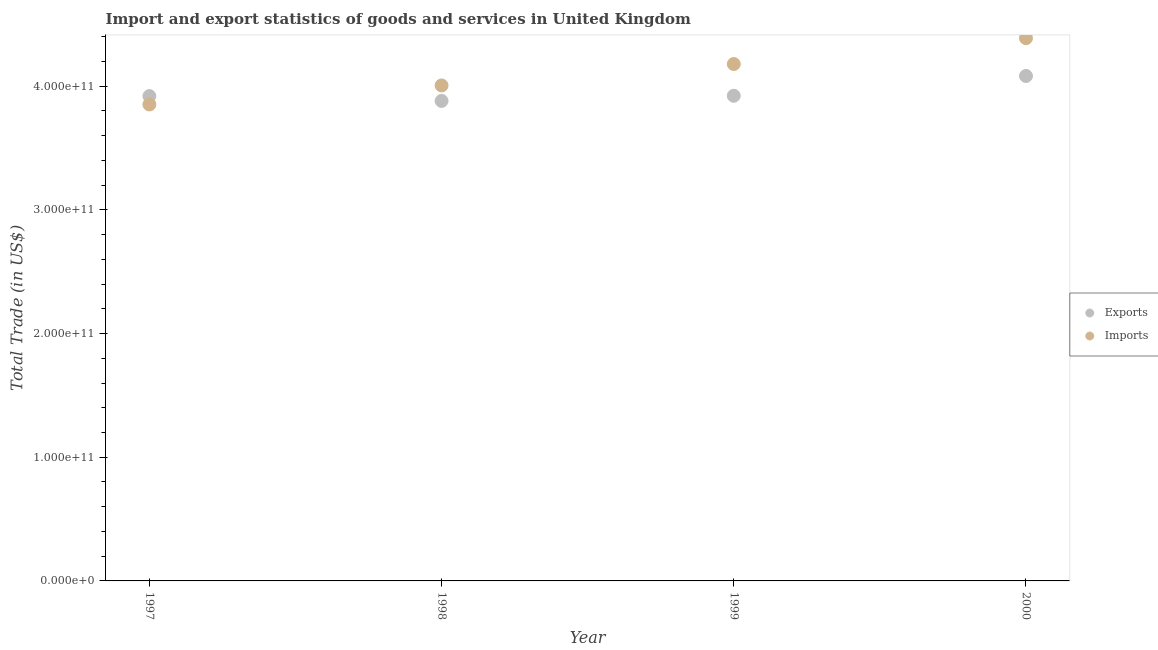Is the number of dotlines equal to the number of legend labels?
Ensure brevity in your answer.  Yes. What is the imports of goods and services in 2000?
Provide a succinct answer. 4.39e+11. Across all years, what is the maximum imports of goods and services?
Your answer should be very brief. 4.39e+11. Across all years, what is the minimum imports of goods and services?
Your response must be concise. 3.85e+11. What is the total export of goods and services in the graph?
Make the answer very short. 1.58e+12. What is the difference between the imports of goods and services in 1997 and that in 2000?
Ensure brevity in your answer.  -5.36e+1. What is the difference between the imports of goods and services in 1999 and the export of goods and services in 2000?
Your answer should be very brief. 9.66e+09. What is the average imports of goods and services per year?
Give a very brief answer. 4.11e+11. In the year 2000, what is the difference between the imports of goods and services and export of goods and services?
Offer a terse response. 3.05e+1. In how many years, is the imports of goods and services greater than 320000000000 US$?
Give a very brief answer. 4. What is the ratio of the imports of goods and services in 1998 to that in 1999?
Provide a short and direct response. 0.96. What is the difference between the highest and the second highest export of goods and services?
Provide a short and direct response. 1.60e+1. What is the difference between the highest and the lowest export of goods and services?
Provide a succinct answer. 2.02e+1. In how many years, is the imports of goods and services greater than the average imports of goods and services taken over all years?
Offer a very short reply. 2. Is the sum of the export of goods and services in 1999 and 2000 greater than the maximum imports of goods and services across all years?
Your answer should be very brief. Yes. Does the imports of goods and services monotonically increase over the years?
Make the answer very short. Yes. Is the imports of goods and services strictly less than the export of goods and services over the years?
Offer a terse response. No. How many dotlines are there?
Offer a very short reply. 2. What is the difference between two consecutive major ticks on the Y-axis?
Your answer should be compact. 1.00e+11. Does the graph contain grids?
Give a very brief answer. No. Where does the legend appear in the graph?
Give a very brief answer. Center right. How many legend labels are there?
Ensure brevity in your answer.  2. How are the legend labels stacked?
Your answer should be compact. Vertical. What is the title of the graph?
Give a very brief answer. Import and export statistics of goods and services in United Kingdom. Does "Goods and services" appear as one of the legend labels in the graph?
Make the answer very short. No. What is the label or title of the Y-axis?
Your answer should be very brief. Total Trade (in US$). What is the Total Trade (in US$) in Exports in 1997?
Your answer should be compact. 3.92e+11. What is the Total Trade (in US$) of Imports in 1997?
Give a very brief answer. 3.85e+11. What is the Total Trade (in US$) in Exports in 1998?
Your answer should be very brief. 3.88e+11. What is the Total Trade (in US$) of Imports in 1998?
Provide a succinct answer. 4.01e+11. What is the Total Trade (in US$) of Exports in 1999?
Your answer should be very brief. 3.92e+11. What is the Total Trade (in US$) of Imports in 1999?
Your response must be concise. 4.18e+11. What is the Total Trade (in US$) of Exports in 2000?
Give a very brief answer. 4.08e+11. What is the Total Trade (in US$) of Imports in 2000?
Provide a succinct answer. 4.39e+11. Across all years, what is the maximum Total Trade (in US$) of Exports?
Keep it short and to the point. 4.08e+11. Across all years, what is the maximum Total Trade (in US$) of Imports?
Keep it short and to the point. 4.39e+11. Across all years, what is the minimum Total Trade (in US$) in Exports?
Offer a terse response. 3.88e+11. Across all years, what is the minimum Total Trade (in US$) of Imports?
Make the answer very short. 3.85e+11. What is the total Total Trade (in US$) in Exports in the graph?
Ensure brevity in your answer.  1.58e+12. What is the total Total Trade (in US$) of Imports in the graph?
Offer a terse response. 1.64e+12. What is the difference between the Total Trade (in US$) of Exports in 1997 and that in 1998?
Provide a succinct answer. 3.92e+09. What is the difference between the Total Trade (in US$) in Imports in 1997 and that in 1998?
Offer a very short reply. -1.54e+1. What is the difference between the Total Trade (in US$) in Exports in 1997 and that in 1999?
Keep it short and to the point. -2.45e+08. What is the difference between the Total Trade (in US$) in Imports in 1997 and that in 1999?
Your response must be concise. -3.27e+1. What is the difference between the Total Trade (in US$) in Exports in 1997 and that in 2000?
Make the answer very short. -1.63e+1. What is the difference between the Total Trade (in US$) of Imports in 1997 and that in 2000?
Provide a succinct answer. -5.36e+1. What is the difference between the Total Trade (in US$) in Exports in 1998 and that in 1999?
Offer a terse response. -4.17e+09. What is the difference between the Total Trade (in US$) in Imports in 1998 and that in 1999?
Make the answer very short. -1.73e+1. What is the difference between the Total Trade (in US$) of Exports in 1998 and that in 2000?
Give a very brief answer. -2.02e+1. What is the difference between the Total Trade (in US$) of Imports in 1998 and that in 2000?
Your answer should be compact. -3.82e+1. What is the difference between the Total Trade (in US$) in Exports in 1999 and that in 2000?
Provide a short and direct response. -1.60e+1. What is the difference between the Total Trade (in US$) in Imports in 1999 and that in 2000?
Give a very brief answer. -2.09e+1. What is the difference between the Total Trade (in US$) in Exports in 1997 and the Total Trade (in US$) in Imports in 1998?
Provide a short and direct response. -8.60e+09. What is the difference between the Total Trade (in US$) in Exports in 1997 and the Total Trade (in US$) in Imports in 1999?
Make the answer very short. -2.59e+1. What is the difference between the Total Trade (in US$) of Exports in 1997 and the Total Trade (in US$) of Imports in 2000?
Your answer should be compact. -4.68e+1. What is the difference between the Total Trade (in US$) of Exports in 1998 and the Total Trade (in US$) of Imports in 1999?
Keep it short and to the point. -2.98e+1. What is the difference between the Total Trade (in US$) of Exports in 1998 and the Total Trade (in US$) of Imports in 2000?
Your answer should be compact. -5.07e+1. What is the difference between the Total Trade (in US$) of Exports in 1999 and the Total Trade (in US$) of Imports in 2000?
Ensure brevity in your answer.  -4.66e+1. What is the average Total Trade (in US$) of Exports per year?
Provide a short and direct response. 3.95e+11. What is the average Total Trade (in US$) in Imports per year?
Provide a short and direct response. 4.11e+11. In the year 1997, what is the difference between the Total Trade (in US$) in Exports and Total Trade (in US$) in Imports?
Provide a short and direct response. 6.78e+09. In the year 1998, what is the difference between the Total Trade (in US$) of Exports and Total Trade (in US$) of Imports?
Give a very brief answer. -1.25e+1. In the year 1999, what is the difference between the Total Trade (in US$) of Exports and Total Trade (in US$) of Imports?
Your response must be concise. -2.57e+1. In the year 2000, what is the difference between the Total Trade (in US$) of Exports and Total Trade (in US$) of Imports?
Provide a short and direct response. -3.05e+1. What is the ratio of the Total Trade (in US$) in Imports in 1997 to that in 1998?
Your answer should be very brief. 0.96. What is the ratio of the Total Trade (in US$) in Imports in 1997 to that in 1999?
Make the answer very short. 0.92. What is the ratio of the Total Trade (in US$) of Exports in 1997 to that in 2000?
Offer a terse response. 0.96. What is the ratio of the Total Trade (in US$) of Imports in 1997 to that in 2000?
Ensure brevity in your answer.  0.88. What is the ratio of the Total Trade (in US$) in Imports in 1998 to that in 1999?
Provide a succinct answer. 0.96. What is the ratio of the Total Trade (in US$) in Exports in 1998 to that in 2000?
Your answer should be compact. 0.95. What is the ratio of the Total Trade (in US$) of Imports in 1998 to that in 2000?
Keep it short and to the point. 0.91. What is the ratio of the Total Trade (in US$) in Exports in 1999 to that in 2000?
Your response must be concise. 0.96. What is the ratio of the Total Trade (in US$) in Imports in 1999 to that in 2000?
Your answer should be compact. 0.95. What is the difference between the highest and the second highest Total Trade (in US$) in Exports?
Your response must be concise. 1.60e+1. What is the difference between the highest and the second highest Total Trade (in US$) in Imports?
Provide a succinct answer. 2.09e+1. What is the difference between the highest and the lowest Total Trade (in US$) of Exports?
Offer a very short reply. 2.02e+1. What is the difference between the highest and the lowest Total Trade (in US$) of Imports?
Offer a very short reply. 5.36e+1. 